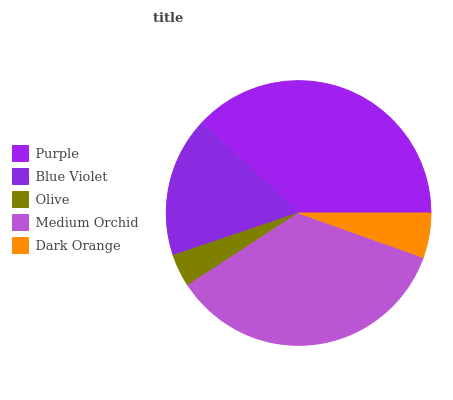Is Olive the minimum?
Answer yes or no. Yes. Is Purple the maximum?
Answer yes or no. Yes. Is Blue Violet the minimum?
Answer yes or no. No. Is Blue Violet the maximum?
Answer yes or no. No. Is Purple greater than Blue Violet?
Answer yes or no. Yes. Is Blue Violet less than Purple?
Answer yes or no. Yes. Is Blue Violet greater than Purple?
Answer yes or no. No. Is Purple less than Blue Violet?
Answer yes or no. No. Is Blue Violet the high median?
Answer yes or no. Yes. Is Blue Violet the low median?
Answer yes or no. Yes. Is Olive the high median?
Answer yes or no. No. Is Purple the low median?
Answer yes or no. No. 